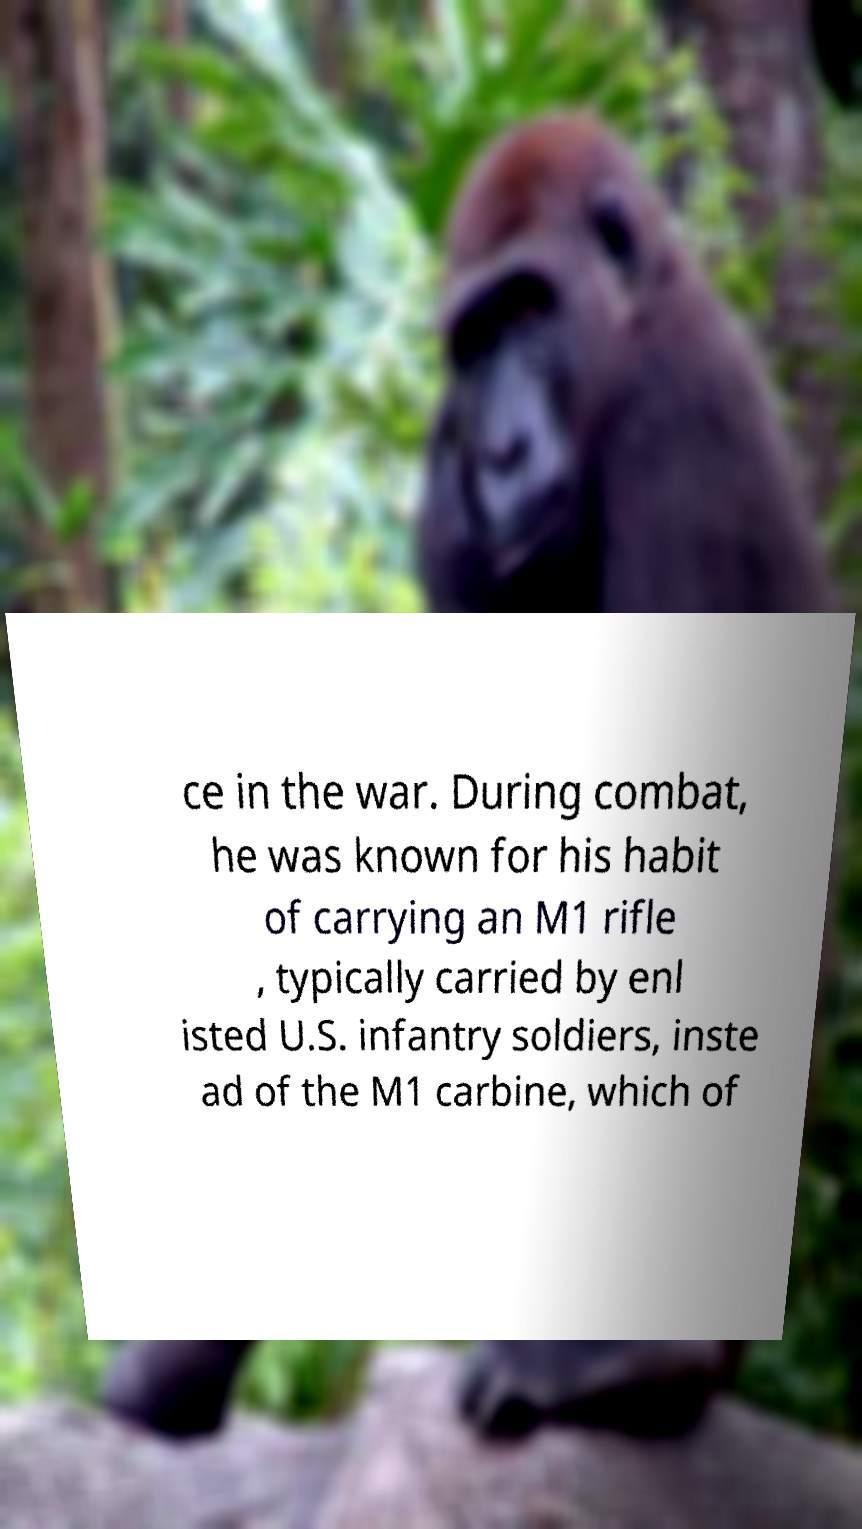Please read and relay the text visible in this image. What does it say? ce in the war. During combat, he was known for his habit of carrying an M1 rifle , typically carried by enl isted U.S. infantry soldiers, inste ad of the M1 carbine, which of 